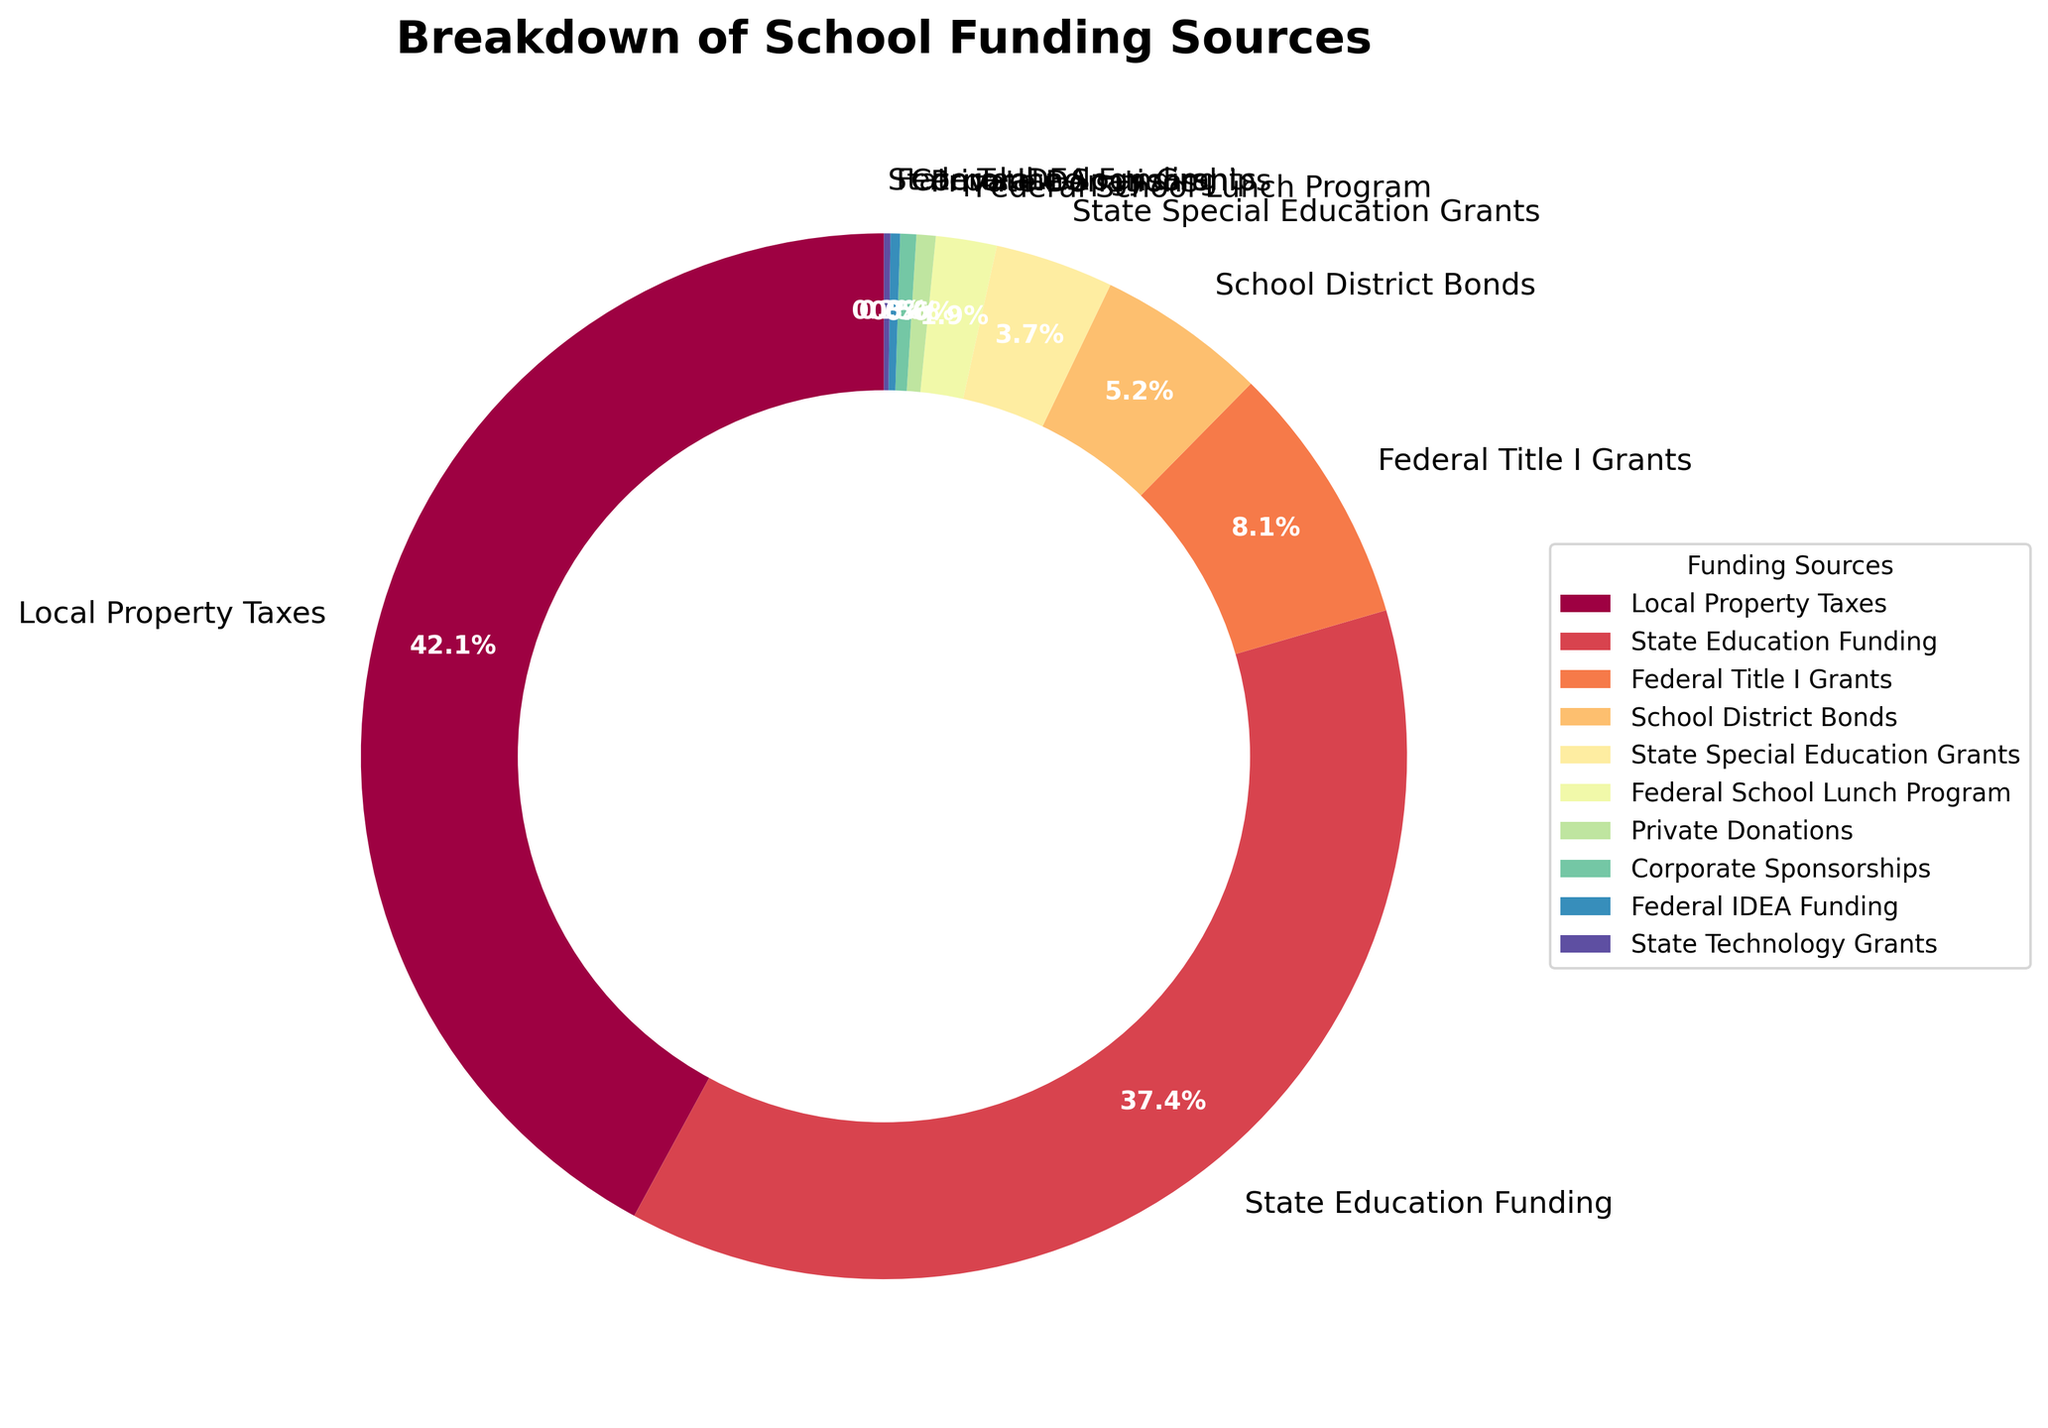What is the largest single source of funding? The largest slice in the pie chart represents the biggest funding source. The "Local Property Taxes" section is the largest one.
Answer: Local Property Taxes Which two funding sources have the closest percentage values? Compare the percentages of all funding sources. "Federal Title I Grants" (8.2%) and "School District Bonds" (5.3%) have the closest values.
Answer: Federal Title I Grants and School District Bonds What is the combined percentage of all federal funding sources? Add the percentages of all federal funding sources: "Federal Title I Grants" (8.2%), "Federal School Lunch Program" (1.9%), "Federal IDEA Funding" (0.3%). 8.2 + 1.9 + 0.3 = 10.4%
Answer: 10.4% Which funding source contributes less than 1%? Look for slices of the pie chart with values less than 1%. "Private Donations" (0.6%), "Corporate Sponsorships" (0.5%), and "Federal IDEA Funding" (0.3%) contribute less than 1%.
Answer: Private Donations, Corporate Sponsorships, and Federal IDEA Funding What is the difference in percentage between Local Property Taxes and State Education Funding? Subtract the percentage of "State Education Funding" (37.8%) from "Local Property Taxes" (42.5%). 42.5 - 37.8 = 4.7
Answer: 4.7 How much more does Local Property Taxes contribute compared to School District Bonds? Subtract the percentage of "School District Bonds" (5.3%) from "Local Property Taxes" (42.5%). 42.5 - 5.3 = 37.2
Answer: 37.2 What percentage of funding comes from state sources? Add the percentages of all state sources: "State Education Funding" (37.8%), "State Special Education Grants" (3.7%), "State Technology Grants" (0.2%). 37.8 + 3.7 + 0.2 = 41.7%
Answer: 41.7% How does the percentage of State Education Funding compare to the combined percentage of all federal funding sources? Compare the percentage of "State Education Funding" (37.8%) and the combined percentage of all federal funding sources (10.4%). State Education Funding is significantly higher.
Answer: State Education Funding is higher Which two funding sources together sum up close to 50%? Look for two sources that sum up to around 50%. "Local Property Taxes" (42.5%) and "State Education Funding" (37.8%) together is 42.5 + 37.8 = 80.3%, which is much higher. However, "Local Property Taxes" (42.5%) and "Federal Title I Grants" (8.2%) together is 42.5 + 8.2 = 50.7%.
Answer: Local Property Taxes and Federal Title I Grants 